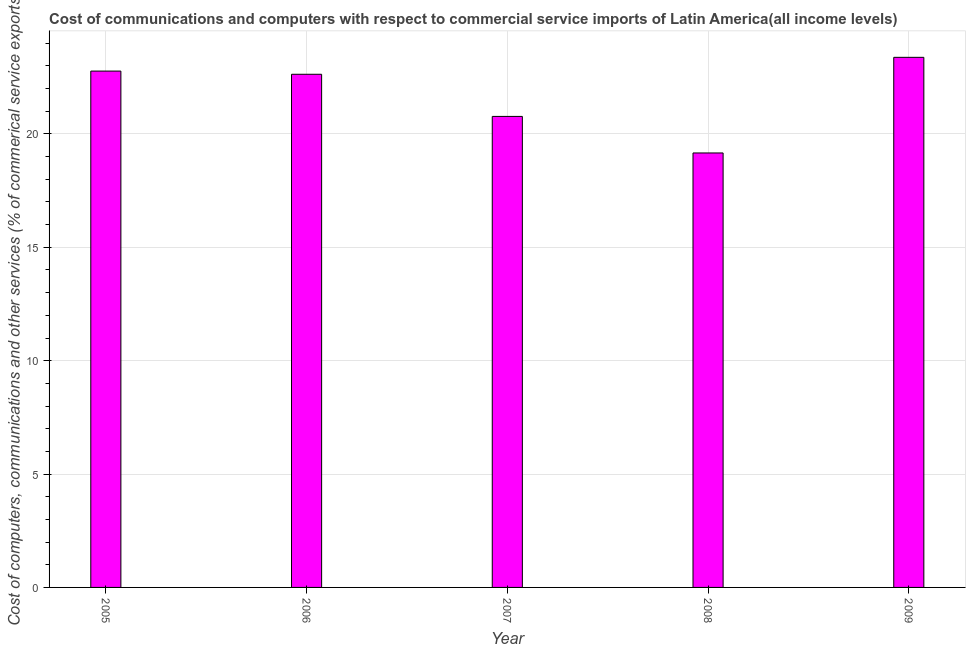Does the graph contain any zero values?
Offer a very short reply. No. What is the title of the graph?
Offer a terse response. Cost of communications and computers with respect to commercial service imports of Latin America(all income levels). What is the label or title of the Y-axis?
Offer a very short reply. Cost of computers, communications and other services (% of commerical service exports). What is the cost of communications in 2006?
Offer a terse response. 22.63. Across all years, what is the maximum  computer and other services?
Your response must be concise. 23.38. Across all years, what is the minimum  computer and other services?
Your answer should be compact. 19.16. In which year was the  computer and other services maximum?
Provide a short and direct response. 2009. What is the sum of the cost of communications?
Keep it short and to the point. 108.72. What is the difference between the cost of communications in 2005 and 2009?
Make the answer very short. -0.61. What is the average  computer and other services per year?
Keep it short and to the point. 21.74. What is the median cost of communications?
Your answer should be very brief. 22.63. In how many years, is the  computer and other services greater than 6 %?
Ensure brevity in your answer.  5. What is the ratio of the cost of communications in 2006 to that in 2008?
Provide a succinct answer. 1.18. Is the cost of communications in 2005 less than that in 2006?
Make the answer very short. No. Is the difference between the cost of communications in 2005 and 2009 greater than the difference between any two years?
Provide a succinct answer. No. What is the difference between the highest and the second highest cost of communications?
Ensure brevity in your answer.  0.61. What is the difference between the highest and the lowest  computer and other services?
Offer a very short reply. 4.22. Are all the bars in the graph horizontal?
Provide a short and direct response. No. What is the difference between two consecutive major ticks on the Y-axis?
Provide a short and direct response. 5. Are the values on the major ticks of Y-axis written in scientific E-notation?
Make the answer very short. No. What is the Cost of computers, communications and other services (% of commerical service exports) of 2005?
Your response must be concise. 22.77. What is the Cost of computers, communications and other services (% of commerical service exports) of 2006?
Provide a succinct answer. 22.63. What is the Cost of computers, communications and other services (% of commerical service exports) of 2007?
Provide a succinct answer. 20.77. What is the Cost of computers, communications and other services (% of commerical service exports) of 2008?
Provide a succinct answer. 19.16. What is the Cost of computers, communications and other services (% of commerical service exports) in 2009?
Your response must be concise. 23.38. What is the difference between the Cost of computers, communications and other services (% of commerical service exports) in 2005 and 2006?
Your answer should be compact. 0.14. What is the difference between the Cost of computers, communications and other services (% of commerical service exports) in 2005 and 2007?
Your response must be concise. 2. What is the difference between the Cost of computers, communications and other services (% of commerical service exports) in 2005 and 2008?
Provide a succinct answer. 3.61. What is the difference between the Cost of computers, communications and other services (% of commerical service exports) in 2005 and 2009?
Offer a terse response. -0.61. What is the difference between the Cost of computers, communications and other services (% of commerical service exports) in 2006 and 2007?
Provide a succinct answer. 1.86. What is the difference between the Cost of computers, communications and other services (% of commerical service exports) in 2006 and 2008?
Give a very brief answer. 3.47. What is the difference between the Cost of computers, communications and other services (% of commerical service exports) in 2006 and 2009?
Your answer should be very brief. -0.75. What is the difference between the Cost of computers, communications and other services (% of commerical service exports) in 2007 and 2008?
Give a very brief answer. 1.61. What is the difference between the Cost of computers, communications and other services (% of commerical service exports) in 2007 and 2009?
Your answer should be very brief. -2.61. What is the difference between the Cost of computers, communications and other services (% of commerical service exports) in 2008 and 2009?
Provide a succinct answer. -4.22. What is the ratio of the Cost of computers, communications and other services (% of commerical service exports) in 2005 to that in 2007?
Offer a terse response. 1.1. What is the ratio of the Cost of computers, communications and other services (% of commerical service exports) in 2005 to that in 2008?
Make the answer very short. 1.19. What is the ratio of the Cost of computers, communications and other services (% of commerical service exports) in 2006 to that in 2007?
Offer a terse response. 1.09. What is the ratio of the Cost of computers, communications and other services (% of commerical service exports) in 2006 to that in 2008?
Give a very brief answer. 1.18. What is the ratio of the Cost of computers, communications and other services (% of commerical service exports) in 2006 to that in 2009?
Your answer should be very brief. 0.97. What is the ratio of the Cost of computers, communications and other services (% of commerical service exports) in 2007 to that in 2008?
Provide a succinct answer. 1.08. What is the ratio of the Cost of computers, communications and other services (% of commerical service exports) in 2007 to that in 2009?
Make the answer very short. 0.89. What is the ratio of the Cost of computers, communications and other services (% of commerical service exports) in 2008 to that in 2009?
Provide a short and direct response. 0.82. 